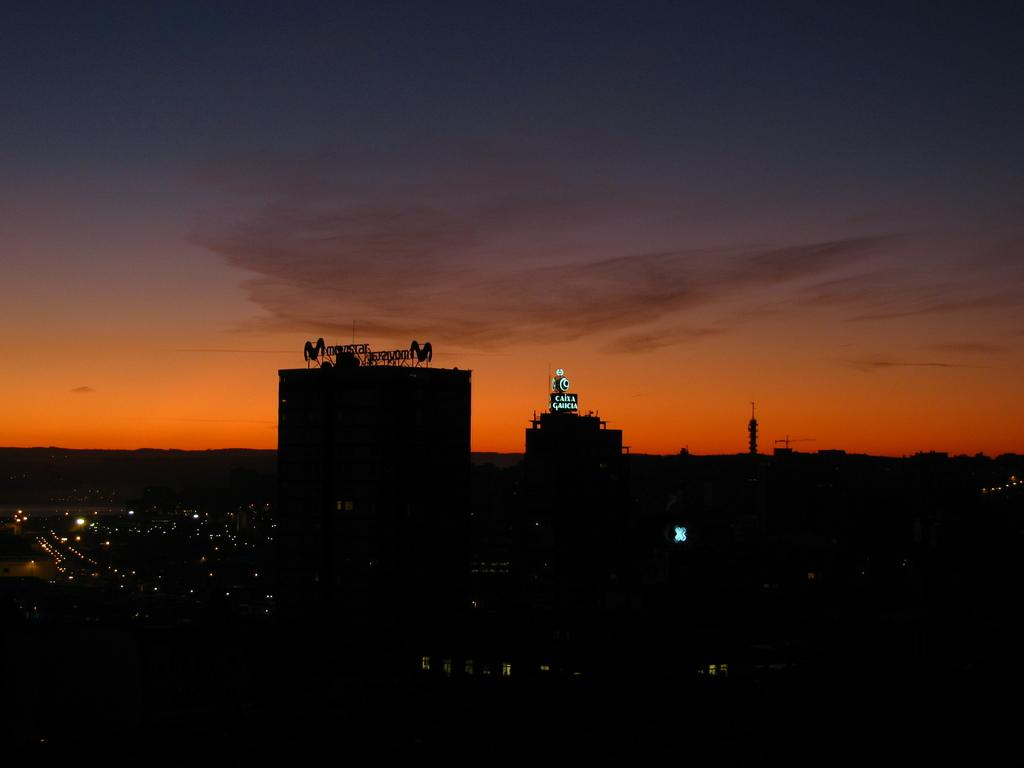What type of structures can be seen in the image? There are buildings in the image. What else is visible in the image besides the buildings? There are lights and birds present in the image. How can the buildings be identified in the image? The buildings have name boards in the image. What is visible in the background of the image? The sky is visible in the image. Where is the cannon hidden in the image? There is no cannon present in the image. What type of pleasure can be experienced by the birds in the image? The image does not provide information about the birds' emotions or experiences, so it cannot be determined if they are experiencing pleasure. 